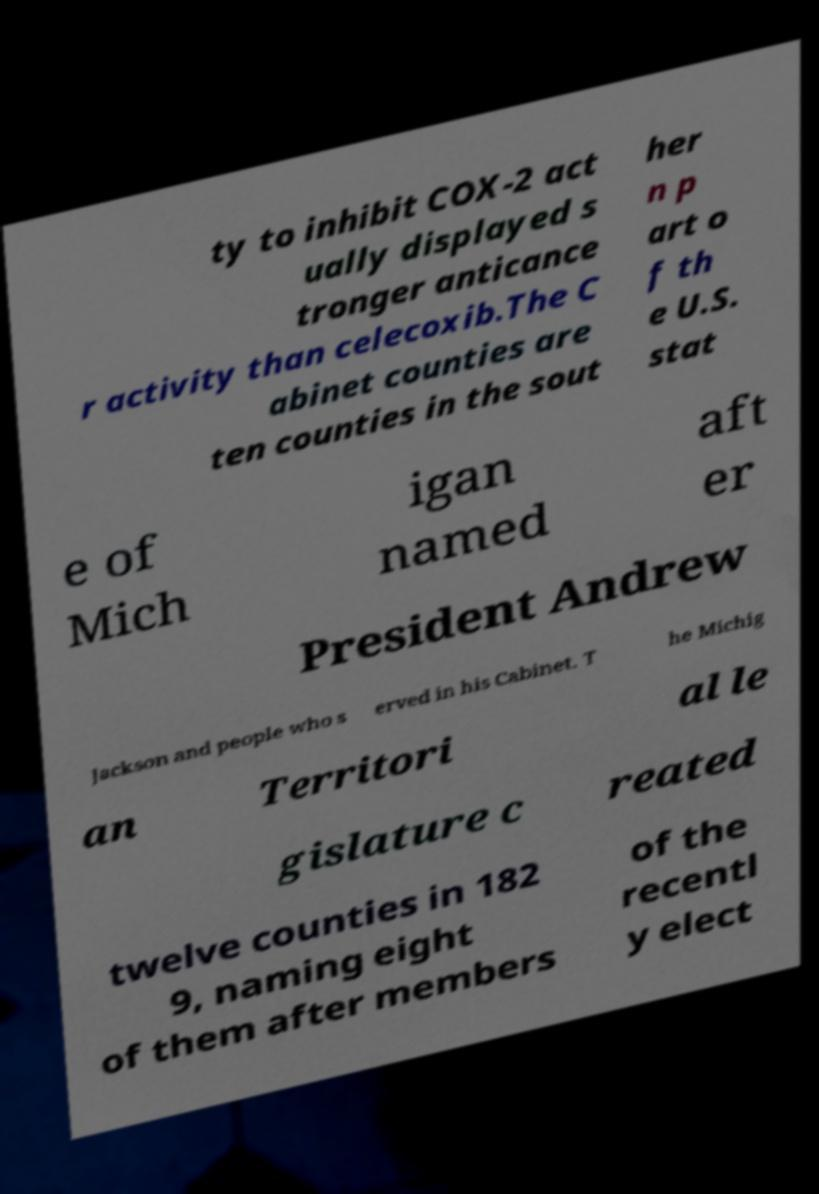There's text embedded in this image that I need extracted. Can you transcribe it verbatim? ty to inhibit COX-2 act ually displayed s tronger anticance r activity than celecoxib.The C abinet counties are ten counties in the sout her n p art o f th e U.S. stat e of Mich igan named aft er President Andrew Jackson and people who s erved in his Cabinet. T he Michig an Territori al le gislature c reated twelve counties in 182 9, naming eight of them after members of the recentl y elect 